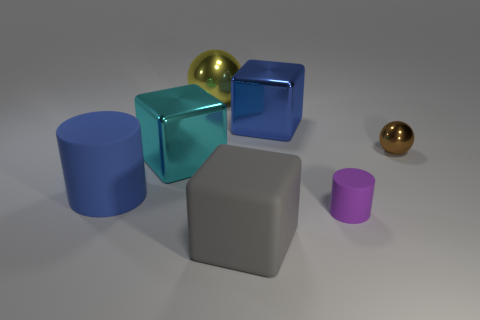Subtract all brown balls. Subtract all blue cylinders. How many balls are left? 1 Add 2 gray shiny cylinders. How many objects exist? 9 Subtract all cubes. How many objects are left? 4 Add 1 small things. How many small things are left? 3 Add 2 big cyan shiny blocks. How many big cyan shiny blocks exist? 3 Subtract 0 red balls. How many objects are left? 7 Subtract all large blue matte cylinders. Subtract all tiny red rubber things. How many objects are left? 6 